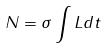<formula> <loc_0><loc_0><loc_500><loc_500>N = \sigma \int L d t</formula> 